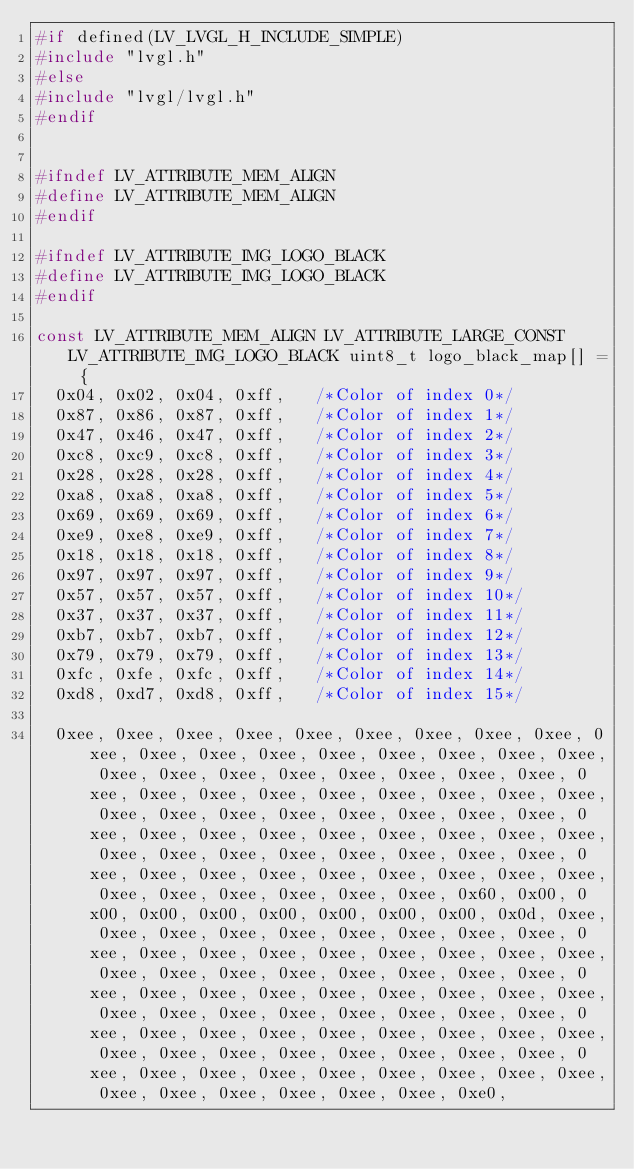<code> <loc_0><loc_0><loc_500><loc_500><_C_>#if defined(LV_LVGL_H_INCLUDE_SIMPLE)
#include "lvgl.h"
#else
#include "lvgl/lvgl.h"
#endif


#ifndef LV_ATTRIBUTE_MEM_ALIGN
#define LV_ATTRIBUTE_MEM_ALIGN
#endif

#ifndef LV_ATTRIBUTE_IMG_LOGO_BLACK
#define LV_ATTRIBUTE_IMG_LOGO_BLACK
#endif

const LV_ATTRIBUTE_MEM_ALIGN LV_ATTRIBUTE_LARGE_CONST LV_ATTRIBUTE_IMG_LOGO_BLACK uint8_t logo_black_map[] = {
  0x04, 0x02, 0x04, 0xff, 	/*Color of index 0*/
  0x87, 0x86, 0x87, 0xff, 	/*Color of index 1*/
  0x47, 0x46, 0x47, 0xff, 	/*Color of index 2*/
  0xc8, 0xc9, 0xc8, 0xff, 	/*Color of index 3*/
  0x28, 0x28, 0x28, 0xff, 	/*Color of index 4*/
  0xa8, 0xa8, 0xa8, 0xff, 	/*Color of index 5*/
  0x69, 0x69, 0x69, 0xff, 	/*Color of index 6*/
  0xe9, 0xe8, 0xe9, 0xff, 	/*Color of index 7*/
  0x18, 0x18, 0x18, 0xff, 	/*Color of index 8*/
  0x97, 0x97, 0x97, 0xff, 	/*Color of index 9*/
  0x57, 0x57, 0x57, 0xff, 	/*Color of index 10*/
  0x37, 0x37, 0x37, 0xff, 	/*Color of index 11*/
  0xb7, 0xb7, 0xb7, 0xff, 	/*Color of index 12*/
  0x79, 0x79, 0x79, 0xff, 	/*Color of index 13*/
  0xfc, 0xfe, 0xfc, 0xff, 	/*Color of index 14*/
  0xd8, 0xd7, 0xd8, 0xff, 	/*Color of index 15*/

  0xee, 0xee, 0xee, 0xee, 0xee, 0xee, 0xee, 0xee, 0xee, 0xee, 0xee, 0xee, 0xee, 0xee, 0xee, 0xee, 0xee, 0xee, 0xee, 0xee, 0xee, 0xee, 0xee, 0xee, 0xee, 0xee, 0xee, 0xee, 0xee, 0xee, 0xee, 0xee, 0xee, 0xee, 0xee, 0xee, 0xee, 0xee, 0xee, 0xee, 0xee, 0xee, 0xee, 0xee, 0xee, 0xee, 0xee, 0xee, 0xee, 0xee, 0xee, 0xee, 0xee, 0xee, 0xee, 0xee, 0xee, 0xee, 0xee, 0xee, 0xee, 0xee, 0xee, 0xee, 0xee, 0xee, 0xee, 0xee, 0xee, 0xee, 0xee, 0xee, 0xee, 0xee, 0xee, 0x60, 0x00, 0x00, 0x00, 0x00, 0x00, 0x00, 0x00, 0x00, 0x0d, 0xee, 0xee, 0xee, 0xee, 0xee, 0xee, 0xee, 0xee, 0xee, 0xee, 0xee, 0xee, 0xee, 0xee, 0xee, 0xee, 0xee, 0xee, 0xee, 0xee, 0xee, 0xee, 0xee, 0xee, 0xee, 0xee, 0xee, 0xee, 0xee, 0xee, 0xee, 0xee, 0xee, 0xee, 0xee, 0xee, 0xee, 0xee, 0xee, 0xee, 0xee, 0xee, 0xee, 0xee, 0xee, 0xee, 0xee, 0xee, 0xee, 0xee, 0xee, 0xee, 0xee, 0xee, 0xee, 0xee, 0xee, 0xee, 0xee, 0xee, 0xee, 0xee, 0xee, 0xee, 0xee, 0xee, 0xee, 0xee, 0xee, 0xee, 0xee, 0xee, 0xee, 0xee, 0xee, 0xe0, </code> 